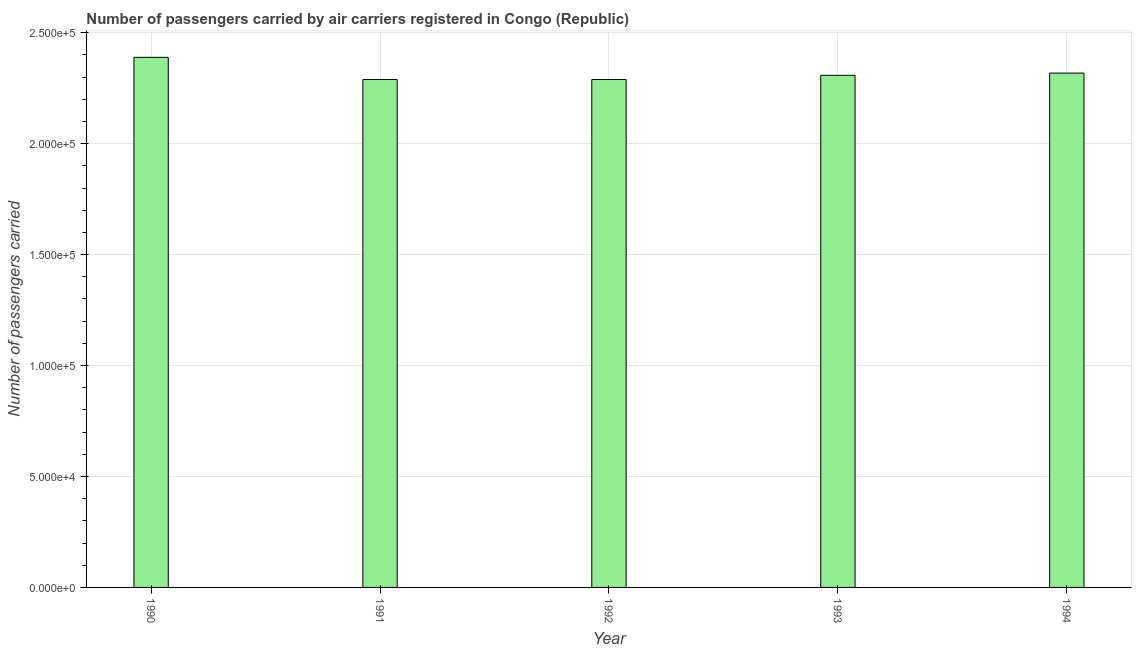Does the graph contain grids?
Provide a short and direct response. Yes. What is the title of the graph?
Make the answer very short. Number of passengers carried by air carriers registered in Congo (Republic). What is the label or title of the X-axis?
Offer a terse response. Year. What is the label or title of the Y-axis?
Offer a terse response. Number of passengers carried. What is the number of passengers carried in 1994?
Keep it short and to the point. 2.32e+05. Across all years, what is the maximum number of passengers carried?
Keep it short and to the point. 2.39e+05. Across all years, what is the minimum number of passengers carried?
Ensure brevity in your answer.  2.29e+05. In which year was the number of passengers carried maximum?
Offer a terse response. 1990. What is the sum of the number of passengers carried?
Provide a short and direct response. 1.16e+06. What is the difference between the number of passengers carried in 1990 and 1994?
Provide a short and direct response. 7100. What is the average number of passengers carried per year?
Make the answer very short. 2.32e+05. What is the median number of passengers carried?
Offer a terse response. 2.31e+05. Do a majority of the years between 1992 and 1994 (inclusive) have number of passengers carried greater than 110000 ?
Offer a very short reply. Yes. What is the difference between the highest and the second highest number of passengers carried?
Offer a very short reply. 7100. Is the sum of the number of passengers carried in 1990 and 1992 greater than the maximum number of passengers carried across all years?
Give a very brief answer. Yes. How many bars are there?
Your answer should be compact. 5. What is the difference between two consecutive major ticks on the Y-axis?
Your answer should be compact. 5.00e+04. Are the values on the major ticks of Y-axis written in scientific E-notation?
Make the answer very short. Yes. What is the Number of passengers carried of 1990?
Ensure brevity in your answer.  2.39e+05. What is the Number of passengers carried in 1991?
Provide a short and direct response. 2.29e+05. What is the Number of passengers carried of 1992?
Provide a short and direct response. 2.29e+05. What is the Number of passengers carried of 1993?
Your response must be concise. 2.31e+05. What is the Number of passengers carried of 1994?
Make the answer very short. 2.32e+05. What is the difference between the Number of passengers carried in 1990 and 1992?
Provide a short and direct response. 10000. What is the difference between the Number of passengers carried in 1990 and 1993?
Your answer should be very brief. 8100. What is the difference between the Number of passengers carried in 1990 and 1994?
Make the answer very short. 7100. What is the difference between the Number of passengers carried in 1991 and 1992?
Make the answer very short. 0. What is the difference between the Number of passengers carried in 1991 and 1993?
Your answer should be very brief. -1900. What is the difference between the Number of passengers carried in 1991 and 1994?
Keep it short and to the point. -2900. What is the difference between the Number of passengers carried in 1992 and 1993?
Give a very brief answer. -1900. What is the difference between the Number of passengers carried in 1992 and 1994?
Ensure brevity in your answer.  -2900. What is the difference between the Number of passengers carried in 1993 and 1994?
Provide a short and direct response. -1000. What is the ratio of the Number of passengers carried in 1990 to that in 1991?
Your answer should be compact. 1.04. What is the ratio of the Number of passengers carried in 1990 to that in 1992?
Provide a short and direct response. 1.04. What is the ratio of the Number of passengers carried in 1990 to that in 1993?
Keep it short and to the point. 1.03. What is the ratio of the Number of passengers carried in 1990 to that in 1994?
Provide a short and direct response. 1.03. What is the ratio of the Number of passengers carried in 1991 to that in 1992?
Give a very brief answer. 1. What is the ratio of the Number of passengers carried in 1991 to that in 1993?
Your answer should be compact. 0.99. What is the ratio of the Number of passengers carried in 1991 to that in 1994?
Keep it short and to the point. 0.99. What is the ratio of the Number of passengers carried in 1992 to that in 1993?
Keep it short and to the point. 0.99. What is the ratio of the Number of passengers carried in 1993 to that in 1994?
Provide a short and direct response. 1. 